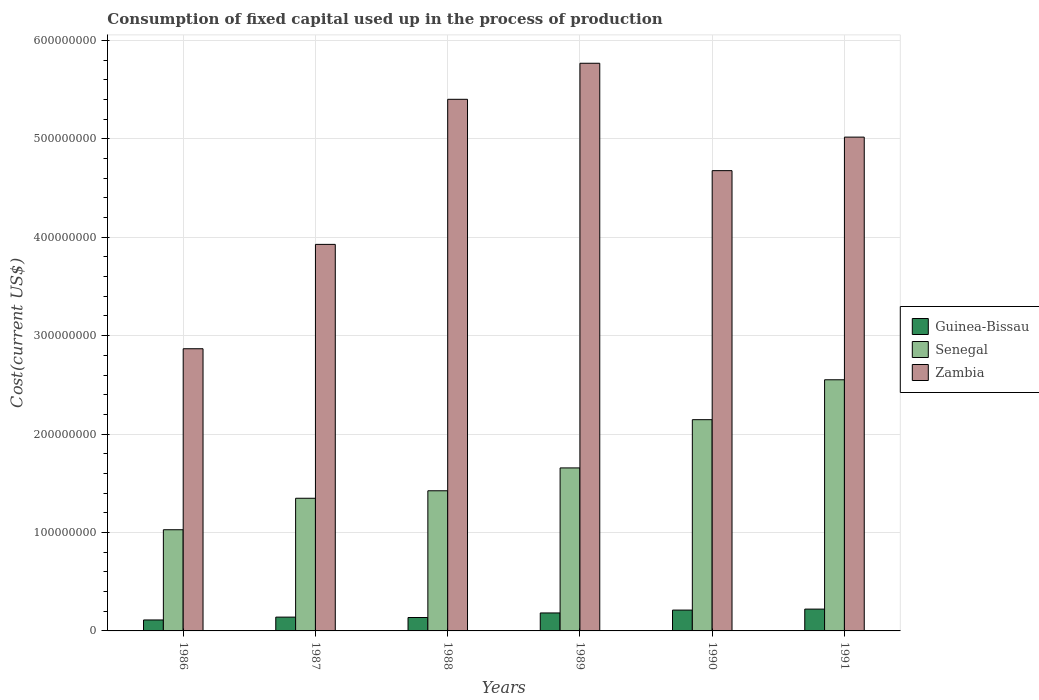How many groups of bars are there?
Ensure brevity in your answer.  6. Are the number of bars on each tick of the X-axis equal?
Provide a succinct answer. Yes. How many bars are there on the 6th tick from the left?
Provide a succinct answer. 3. What is the label of the 4th group of bars from the left?
Offer a very short reply. 1989. In how many cases, is the number of bars for a given year not equal to the number of legend labels?
Make the answer very short. 0. What is the amount consumed in the process of production in Zambia in 1987?
Offer a terse response. 3.93e+08. Across all years, what is the maximum amount consumed in the process of production in Zambia?
Provide a short and direct response. 5.77e+08. Across all years, what is the minimum amount consumed in the process of production in Senegal?
Give a very brief answer. 1.03e+08. In which year was the amount consumed in the process of production in Senegal maximum?
Offer a terse response. 1991. In which year was the amount consumed in the process of production in Zambia minimum?
Your answer should be very brief. 1986. What is the total amount consumed in the process of production in Zambia in the graph?
Ensure brevity in your answer.  2.77e+09. What is the difference between the amount consumed in the process of production in Senegal in 1987 and that in 1991?
Provide a short and direct response. -1.20e+08. What is the difference between the amount consumed in the process of production in Guinea-Bissau in 1988 and the amount consumed in the process of production in Zambia in 1989?
Give a very brief answer. -5.63e+08. What is the average amount consumed in the process of production in Senegal per year?
Your answer should be compact. 1.69e+08. In the year 1991, what is the difference between the amount consumed in the process of production in Zambia and amount consumed in the process of production in Guinea-Bissau?
Provide a succinct answer. 4.80e+08. In how many years, is the amount consumed in the process of production in Senegal greater than 120000000 US$?
Your response must be concise. 5. What is the ratio of the amount consumed in the process of production in Senegal in 1989 to that in 1990?
Offer a terse response. 0.77. Is the amount consumed in the process of production in Zambia in 1986 less than that in 1988?
Offer a very short reply. Yes. Is the difference between the amount consumed in the process of production in Zambia in 1986 and 1989 greater than the difference between the amount consumed in the process of production in Guinea-Bissau in 1986 and 1989?
Make the answer very short. No. What is the difference between the highest and the second highest amount consumed in the process of production in Guinea-Bissau?
Provide a succinct answer. 9.94e+05. What is the difference between the highest and the lowest amount consumed in the process of production in Guinea-Bissau?
Keep it short and to the point. 1.10e+07. What does the 2nd bar from the left in 1991 represents?
Give a very brief answer. Senegal. What does the 2nd bar from the right in 1988 represents?
Provide a succinct answer. Senegal. How many legend labels are there?
Offer a very short reply. 3. What is the title of the graph?
Ensure brevity in your answer.  Consumption of fixed capital used up in the process of production. What is the label or title of the X-axis?
Offer a terse response. Years. What is the label or title of the Y-axis?
Your answer should be very brief. Cost(current US$). What is the Cost(current US$) in Guinea-Bissau in 1986?
Make the answer very short. 1.11e+07. What is the Cost(current US$) of Senegal in 1986?
Offer a very short reply. 1.03e+08. What is the Cost(current US$) of Zambia in 1986?
Your answer should be very brief. 2.87e+08. What is the Cost(current US$) in Guinea-Bissau in 1987?
Provide a short and direct response. 1.40e+07. What is the Cost(current US$) of Senegal in 1987?
Provide a short and direct response. 1.35e+08. What is the Cost(current US$) in Zambia in 1987?
Provide a short and direct response. 3.93e+08. What is the Cost(current US$) in Guinea-Bissau in 1988?
Ensure brevity in your answer.  1.36e+07. What is the Cost(current US$) in Senegal in 1988?
Make the answer very short. 1.42e+08. What is the Cost(current US$) of Zambia in 1988?
Your response must be concise. 5.40e+08. What is the Cost(current US$) of Guinea-Bissau in 1989?
Make the answer very short. 1.83e+07. What is the Cost(current US$) in Senegal in 1989?
Ensure brevity in your answer.  1.66e+08. What is the Cost(current US$) in Zambia in 1989?
Ensure brevity in your answer.  5.77e+08. What is the Cost(current US$) in Guinea-Bissau in 1990?
Your answer should be compact. 2.12e+07. What is the Cost(current US$) in Senegal in 1990?
Your answer should be compact. 2.15e+08. What is the Cost(current US$) in Zambia in 1990?
Offer a very short reply. 4.68e+08. What is the Cost(current US$) in Guinea-Bissau in 1991?
Keep it short and to the point. 2.22e+07. What is the Cost(current US$) of Senegal in 1991?
Keep it short and to the point. 2.55e+08. What is the Cost(current US$) of Zambia in 1991?
Provide a succinct answer. 5.02e+08. Across all years, what is the maximum Cost(current US$) of Guinea-Bissau?
Your response must be concise. 2.22e+07. Across all years, what is the maximum Cost(current US$) of Senegal?
Ensure brevity in your answer.  2.55e+08. Across all years, what is the maximum Cost(current US$) in Zambia?
Provide a short and direct response. 5.77e+08. Across all years, what is the minimum Cost(current US$) of Guinea-Bissau?
Keep it short and to the point. 1.11e+07. Across all years, what is the minimum Cost(current US$) of Senegal?
Ensure brevity in your answer.  1.03e+08. Across all years, what is the minimum Cost(current US$) of Zambia?
Provide a short and direct response. 2.87e+08. What is the total Cost(current US$) of Guinea-Bissau in the graph?
Offer a terse response. 1.00e+08. What is the total Cost(current US$) in Senegal in the graph?
Your answer should be very brief. 1.02e+09. What is the total Cost(current US$) of Zambia in the graph?
Ensure brevity in your answer.  2.77e+09. What is the difference between the Cost(current US$) of Guinea-Bissau in 1986 and that in 1987?
Your answer should be compact. -2.90e+06. What is the difference between the Cost(current US$) of Senegal in 1986 and that in 1987?
Offer a terse response. -3.20e+07. What is the difference between the Cost(current US$) in Zambia in 1986 and that in 1987?
Provide a succinct answer. -1.06e+08. What is the difference between the Cost(current US$) of Guinea-Bissau in 1986 and that in 1988?
Provide a succinct answer. -2.50e+06. What is the difference between the Cost(current US$) in Senegal in 1986 and that in 1988?
Your answer should be compact. -3.96e+07. What is the difference between the Cost(current US$) in Zambia in 1986 and that in 1988?
Offer a terse response. -2.53e+08. What is the difference between the Cost(current US$) of Guinea-Bissau in 1986 and that in 1989?
Your response must be concise. -7.13e+06. What is the difference between the Cost(current US$) of Senegal in 1986 and that in 1989?
Provide a short and direct response. -6.28e+07. What is the difference between the Cost(current US$) in Zambia in 1986 and that in 1989?
Make the answer very short. -2.90e+08. What is the difference between the Cost(current US$) of Guinea-Bissau in 1986 and that in 1990?
Give a very brief answer. -1.00e+07. What is the difference between the Cost(current US$) of Senegal in 1986 and that in 1990?
Your answer should be compact. -1.12e+08. What is the difference between the Cost(current US$) in Zambia in 1986 and that in 1990?
Your response must be concise. -1.81e+08. What is the difference between the Cost(current US$) in Guinea-Bissau in 1986 and that in 1991?
Offer a terse response. -1.10e+07. What is the difference between the Cost(current US$) in Senegal in 1986 and that in 1991?
Provide a succinct answer. -1.52e+08. What is the difference between the Cost(current US$) of Zambia in 1986 and that in 1991?
Ensure brevity in your answer.  -2.15e+08. What is the difference between the Cost(current US$) in Guinea-Bissau in 1987 and that in 1988?
Your response must be concise. 4.03e+05. What is the difference between the Cost(current US$) of Senegal in 1987 and that in 1988?
Keep it short and to the point. -7.61e+06. What is the difference between the Cost(current US$) in Zambia in 1987 and that in 1988?
Offer a terse response. -1.47e+08. What is the difference between the Cost(current US$) of Guinea-Bissau in 1987 and that in 1989?
Make the answer very short. -4.23e+06. What is the difference between the Cost(current US$) of Senegal in 1987 and that in 1989?
Offer a terse response. -3.08e+07. What is the difference between the Cost(current US$) in Zambia in 1987 and that in 1989?
Give a very brief answer. -1.84e+08. What is the difference between the Cost(current US$) of Guinea-Bissau in 1987 and that in 1990?
Give a very brief answer. -7.14e+06. What is the difference between the Cost(current US$) of Senegal in 1987 and that in 1990?
Give a very brief answer. -7.98e+07. What is the difference between the Cost(current US$) in Zambia in 1987 and that in 1990?
Keep it short and to the point. -7.49e+07. What is the difference between the Cost(current US$) of Guinea-Bissau in 1987 and that in 1991?
Provide a succinct answer. -8.14e+06. What is the difference between the Cost(current US$) of Senegal in 1987 and that in 1991?
Provide a short and direct response. -1.20e+08. What is the difference between the Cost(current US$) in Zambia in 1987 and that in 1991?
Your answer should be compact. -1.09e+08. What is the difference between the Cost(current US$) in Guinea-Bissau in 1988 and that in 1989?
Ensure brevity in your answer.  -4.64e+06. What is the difference between the Cost(current US$) of Senegal in 1988 and that in 1989?
Offer a very short reply. -2.32e+07. What is the difference between the Cost(current US$) of Zambia in 1988 and that in 1989?
Your answer should be compact. -3.66e+07. What is the difference between the Cost(current US$) of Guinea-Bissau in 1988 and that in 1990?
Offer a terse response. -7.55e+06. What is the difference between the Cost(current US$) in Senegal in 1988 and that in 1990?
Your response must be concise. -7.22e+07. What is the difference between the Cost(current US$) of Zambia in 1988 and that in 1990?
Your answer should be compact. 7.25e+07. What is the difference between the Cost(current US$) in Guinea-Bissau in 1988 and that in 1991?
Offer a very short reply. -8.54e+06. What is the difference between the Cost(current US$) in Senegal in 1988 and that in 1991?
Provide a short and direct response. -1.13e+08. What is the difference between the Cost(current US$) in Zambia in 1988 and that in 1991?
Offer a very short reply. 3.84e+07. What is the difference between the Cost(current US$) in Guinea-Bissau in 1989 and that in 1990?
Your answer should be very brief. -2.91e+06. What is the difference between the Cost(current US$) in Senegal in 1989 and that in 1990?
Your answer should be very brief. -4.90e+07. What is the difference between the Cost(current US$) in Zambia in 1989 and that in 1990?
Your response must be concise. 1.09e+08. What is the difference between the Cost(current US$) of Guinea-Bissau in 1989 and that in 1991?
Give a very brief answer. -3.91e+06. What is the difference between the Cost(current US$) in Senegal in 1989 and that in 1991?
Provide a succinct answer. -8.96e+07. What is the difference between the Cost(current US$) of Zambia in 1989 and that in 1991?
Your response must be concise. 7.51e+07. What is the difference between the Cost(current US$) of Guinea-Bissau in 1990 and that in 1991?
Provide a short and direct response. -9.94e+05. What is the difference between the Cost(current US$) in Senegal in 1990 and that in 1991?
Make the answer very short. -4.06e+07. What is the difference between the Cost(current US$) in Zambia in 1990 and that in 1991?
Keep it short and to the point. -3.41e+07. What is the difference between the Cost(current US$) of Guinea-Bissau in 1986 and the Cost(current US$) of Senegal in 1987?
Your answer should be very brief. -1.24e+08. What is the difference between the Cost(current US$) in Guinea-Bissau in 1986 and the Cost(current US$) in Zambia in 1987?
Give a very brief answer. -3.82e+08. What is the difference between the Cost(current US$) in Senegal in 1986 and the Cost(current US$) in Zambia in 1987?
Provide a succinct answer. -2.90e+08. What is the difference between the Cost(current US$) in Guinea-Bissau in 1986 and the Cost(current US$) in Senegal in 1988?
Your response must be concise. -1.31e+08. What is the difference between the Cost(current US$) in Guinea-Bissau in 1986 and the Cost(current US$) in Zambia in 1988?
Give a very brief answer. -5.29e+08. What is the difference between the Cost(current US$) of Senegal in 1986 and the Cost(current US$) of Zambia in 1988?
Your response must be concise. -4.37e+08. What is the difference between the Cost(current US$) in Guinea-Bissau in 1986 and the Cost(current US$) in Senegal in 1989?
Give a very brief answer. -1.55e+08. What is the difference between the Cost(current US$) of Guinea-Bissau in 1986 and the Cost(current US$) of Zambia in 1989?
Provide a short and direct response. -5.66e+08. What is the difference between the Cost(current US$) of Senegal in 1986 and the Cost(current US$) of Zambia in 1989?
Offer a very short reply. -4.74e+08. What is the difference between the Cost(current US$) of Guinea-Bissau in 1986 and the Cost(current US$) of Senegal in 1990?
Provide a short and direct response. -2.04e+08. What is the difference between the Cost(current US$) in Guinea-Bissau in 1986 and the Cost(current US$) in Zambia in 1990?
Provide a short and direct response. -4.57e+08. What is the difference between the Cost(current US$) of Senegal in 1986 and the Cost(current US$) of Zambia in 1990?
Your answer should be compact. -3.65e+08. What is the difference between the Cost(current US$) of Guinea-Bissau in 1986 and the Cost(current US$) of Senegal in 1991?
Provide a succinct answer. -2.44e+08. What is the difference between the Cost(current US$) in Guinea-Bissau in 1986 and the Cost(current US$) in Zambia in 1991?
Provide a succinct answer. -4.91e+08. What is the difference between the Cost(current US$) in Senegal in 1986 and the Cost(current US$) in Zambia in 1991?
Keep it short and to the point. -3.99e+08. What is the difference between the Cost(current US$) of Guinea-Bissau in 1987 and the Cost(current US$) of Senegal in 1988?
Your response must be concise. -1.28e+08. What is the difference between the Cost(current US$) in Guinea-Bissau in 1987 and the Cost(current US$) in Zambia in 1988?
Offer a terse response. -5.26e+08. What is the difference between the Cost(current US$) in Senegal in 1987 and the Cost(current US$) in Zambia in 1988?
Your response must be concise. -4.05e+08. What is the difference between the Cost(current US$) in Guinea-Bissau in 1987 and the Cost(current US$) in Senegal in 1989?
Keep it short and to the point. -1.52e+08. What is the difference between the Cost(current US$) in Guinea-Bissau in 1987 and the Cost(current US$) in Zambia in 1989?
Your response must be concise. -5.63e+08. What is the difference between the Cost(current US$) in Senegal in 1987 and the Cost(current US$) in Zambia in 1989?
Offer a terse response. -4.42e+08. What is the difference between the Cost(current US$) in Guinea-Bissau in 1987 and the Cost(current US$) in Senegal in 1990?
Give a very brief answer. -2.01e+08. What is the difference between the Cost(current US$) of Guinea-Bissau in 1987 and the Cost(current US$) of Zambia in 1990?
Make the answer very short. -4.54e+08. What is the difference between the Cost(current US$) of Senegal in 1987 and the Cost(current US$) of Zambia in 1990?
Offer a very short reply. -3.33e+08. What is the difference between the Cost(current US$) of Guinea-Bissau in 1987 and the Cost(current US$) of Senegal in 1991?
Offer a very short reply. -2.41e+08. What is the difference between the Cost(current US$) in Guinea-Bissau in 1987 and the Cost(current US$) in Zambia in 1991?
Offer a terse response. -4.88e+08. What is the difference between the Cost(current US$) of Senegal in 1987 and the Cost(current US$) of Zambia in 1991?
Your answer should be compact. -3.67e+08. What is the difference between the Cost(current US$) of Guinea-Bissau in 1988 and the Cost(current US$) of Senegal in 1989?
Your answer should be very brief. -1.52e+08. What is the difference between the Cost(current US$) in Guinea-Bissau in 1988 and the Cost(current US$) in Zambia in 1989?
Keep it short and to the point. -5.63e+08. What is the difference between the Cost(current US$) in Senegal in 1988 and the Cost(current US$) in Zambia in 1989?
Make the answer very short. -4.34e+08. What is the difference between the Cost(current US$) in Guinea-Bissau in 1988 and the Cost(current US$) in Senegal in 1990?
Your answer should be very brief. -2.01e+08. What is the difference between the Cost(current US$) of Guinea-Bissau in 1988 and the Cost(current US$) of Zambia in 1990?
Offer a terse response. -4.54e+08. What is the difference between the Cost(current US$) in Senegal in 1988 and the Cost(current US$) in Zambia in 1990?
Give a very brief answer. -3.25e+08. What is the difference between the Cost(current US$) of Guinea-Bissau in 1988 and the Cost(current US$) of Senegal in 1991?
Ensure brevity in your answer.  -2.42e+08. What is the difference between the Cost(current US$) in Guinea-Bissau in 1988 and the Cost(current US$) in Zambia in 1991?
Your answer should be very brief. -4.88e+08. What is the difference between the Cost(current US$) of Senegal in 1988 and the Cost(current US$) of Zambia in 1991?
Offer a very short reply. -3.59e+08. What is the difference between the Cost(current US$) in Guinea-Bissau in 1989 and the Cost(current US$) in Senegal in 1990?
Make the answer very short. -1.96e+08. What is the difference between the Cost(current US$) in Guinea-Bissau in 1989 and the Cost(current US$) in Zambia in 1990?
Give a very brief answer. -4.49e+08. What is the difference between the Cost(current US$) in Senegal in 1989 and the Cost(current US$) in Zambia in 1990?
Your answer should be compact. -3.02e+08. What is the difference between the Cost(current US$) in Guinea-Bissau in 1989 and the Cost(current US$) in Senegal in 1991?
Keep it short and to the point. -2.37e+08. What is the difference between the Cost(current US$) in Guinea-Bissau in 1989 and the Cost(current US$) in Zambia in 1991?
Offer a terse response. -4.83e+08. What is the difference between the Cost(current US$) in Senegal in 1989 and the Cost(current US$) in Zambia in 1991?
Offer a very short reply. -3.36e+08. What is the difference between the Cost(current US$) in Guinea-Bissau in 1990 and the Cost(current US$) in Senegal in 1991?
Your answer should be very brief. -2.34e+08. What is the difference between the Cost(current US$) of Guinea-Bissau in 1990 and the Cost(current US$) of Zambia in 1991?
Provide a short and direct response. -4.81e+08. What is the difference between the Cost(current US$) of Senegal in 1990 and the Cost(current US$) of Zambia in 1991?
Provide a short and direct response. -2.87e+08. What is the average Cost(current US$) of Guinea-Bissau per year?
Give a very brief answer. 1.67e+07. What is the average Cost(current US$) in Senegal per year?
Your answer should be compact. 1.69e+08. What is the average Cost(current US$) in Zambia per year?
Your answer should be very brief. 4.61e+08. In the year 1986, what is the difference between the Cost(current US$) in Guinea-Bissau and Cost(current US$) in Senegal?
Your answer should be very brief. -9.17e+07. In the year 1986, what is the difference between the Cost(current US$) of Guinea-Bissau and Cost(current US$) of Zambia?
Offer a terse response. -2.76e+08. In the year 1986, what is the difference between the Cost(current US$) of Senegal and Cost(current US$) of Zambia?
Provide a succinct answer. -1.84e+08. In the year 1987, what is the difference between the Cost(current US$) in Guinea-Bissau and Cost(current US$) in Senegal?
Provide a succinct answer. -1.21e+08. In the year 1987, what is the difference between the Cost(current US$) of Guinea-Bissau and Cost(current US$) of Zambia?
Your response must be concise. -3.79e+08. In the year 1987, what is the difference between the Cost(current US$) of Senegal and Cost(current US$) of Zambia?
Your response must be concise. -2.58e+08. In the year 1988, what is the difference between the Cost(current US$) in Guinea-Bissau and Cost(current US$) in Senegal?
Make the answer very short. -1.29e+08. In the year 1988, what is the difference between the Cost(current US$) of Guinea-Bissau and Cost(current US$) of Zambia?
Make the answer very short. -5.27e+08. In the year 1988, what is the difference between the Cost(current US$) of Senegal and Cost(current US$) of Zambia?
Make the answer very short. -3.98e+08. In the year 1989, what is the difference between the Cost(current US$) in Guinea-Bissau and Cost(current US$) in Senegal?
Your answer should be very brief. -1.47e+08. In the year 1989, what is the difference between the Cost(current US$) of Guinea-Bissau and Cost(current US$) of Zambia?
Offer a terse response. -5.59e+08. In the year 1989, what is the difference between the Cost(current US$) of Senegal and Cost(current US$) of Zambia?
Offer a terse response. -4.11e+08. In the year 1990, what is the difference between the Cost(current US$) in Guinea-Bissau and Cost(current US$) in Senegal?
Provide a short and direct response. -1.93e+08. In the year 1990, what is the difference between the Cost(current US$) in Guinea-Bissau and Cost(current US$) in Zambia?
Offer a terse response. -4.47e+08. In the year 1990, what is the difference between the Cost(current US$) of Senegal and Cost(current US$) of Zambia?
Make the answer very short. -2.53e+08. In the year 1991, what is the difference between the Cost(current US$) in Guinea-Bissau and Cost(current US$) in Senegal?
Your answer should be compact. -2.33e+08. In the year 1991, what is the difference between the Cost(current US$) in Guinea-Bissau and Cost(current US$) in Zambia?
Offer a very short reply. -4.80e+08. In the year 1991, what is the difference between the Cost(current US$) in Senegal and Cost(current US$) in Zambia?
Make the answer very short. -2.47e+08. What is the ratio of the Cost(current US$) in Guinea-Bissau in 1986 to that in 1987?
Make the answer very short. 0.79. What is the ratio of the Cost(current US$) of Senegal in 1986 to that in 1987?
Make the answer very short. 0.76. What is the ratio of the Cost(current US$) of Zambia in 1986 to that in 1987?
Offer a terse response. 0.73. What is the ratio of the Cost(current US$) in Guinea-Bissau in 1986 to that in 1988?
Your answer should be compact. 0.82. What is the ratio of the Cost(current US$) of Senegal in 1986 to that in 1988?
Your answer should be very brief. 0.72. What is the ratio of the Cost(current US$) in Zambia in 1986 to that in 1988?
Give a very brief answer. 0.53. What is the ratio of the Cost(current US$) of Guinea-Bissau in 1986 to that in 1989?
Give a very brief answer. 0.61. What is the ratio of the Cost(current US$) in Senegal in 1986 to that in 1989?
Your response must be concise. 0.62. What is the ratio of the Cost(current US$) of Zambia in 1986 to that in 1989?
Offer a terse response. 0.5. What is the ratio of the Cost(current US$) in Guinea-Bissau in 1986 to that in 1990?
Your answer should be very brief. 0.53. What is the ratio of the Cost(current US$) of Senegal in 1986 to that in 1990?
Keep it short and to the point. 0.48. What is the ratio of the Cost(current US$) of Zambia in 1986 to that in 1990?
Keep it short and to the point. 0.61. What is the ratio of the Cost(current US$) of Guinea-Bissau in 1986 to that in 1991?
Offer a very short reply. 0.5. What is the ratio of the Cost(current US$) of Senegal in 1986 to that in 1991?
Ensure brevity in your answer.  0.4. What is the ratio of the Cost(current US$) of Guinea-Bissau in 1987 to that in 1988?
Offer a terse response. 1.03. What is the ratio of the Cost(current US$) in Senegal in 1987 to that in 1988?
Ensure brevity in your answer.  0.95. What is the ratio of the Cost(current US$) in Zambia in 1987 to that in 1988?
Your answer should be compact. 0.73. What is the ratio of the Cost(current US$) of Guinea-Bissau in 1987 to that in 1989?
Your response must be concise. 0.77. What is the ratio of the Cost(current US$) in Senegal in 1987 to that in 1989?
Provide a short and direct response. 0.81. What is the ratio of the Cost(current US$) in Zambia in 1987 to that in 1989?
Your response must be concise. 0.68. What is the ratio of the Cost(current US$) of Guinea-Bissau in 1987 to that in 1990?
Provide a short and direct response. 0.66. What is the ratio of the Cost(current US$) in Senegal in 1987 to that in 1990?
Your answer should be very brief. 0.63. What is the ratio of the Cost(current US$) in Zambia in 1987 to that in 1990?
Give a very brief answer. 0.84. What is the ratio of the Cost(current US$) of Guinea-Bissau in 1987 to that in 1991?
Provide a succinct answer. 0.63. What is the ratio of the Cost(current US$) of Senegal in 1987 to that in 1991?
Your answer should be very brief. 0.53. What is the ratio of the Cost(current US$) in Zambia in 1987 to that in 1991?
Offer a terse response. 0.78. What is the ratio of the Cost(current US$) in Guinea-Bissau in 1988 to that in 1989?
Make the answer very short. 0.75. What is the ratio of the Cost(current US$) of Senegal in 1988 to that in 1989?
Offer a terse response. 0.86. What is the ratio of the Cost(current US$) of Zambia in 1988 to that in 1989?
Your answer should be very brief. 0.94. What is the ratio of the Cost(current US$) of Guinea-Bissau in 1988 to that in 1990?
Provide a short and direct response. 0.64. What is the ratio of the Cost(current US$) in Senegal in 1988 to that in 1990?
Provide a short and direct response. 0.66. What is the ratio of the Cost(current US$) in Zambia in 1988 to that in 1990?
Your answer should be very brief. 1.16. What is the ratio of the Cost(current US$) of Guinea-Bissau in 1988 to that in 1991?
Your response must be concise. 0.61. What is the ratio of the Cost(current US$) in Senegal in 1988 to that in 1991?
Your response must be concise. 0.56. What is the ratio of the Cost(current US$) of Zambia in 1988 to that in 1991?
Your answer should be very brief. 1.08. What is the ratio of the Cost(current US$) in Guinea-Bissau in 1989 to that in 1990?
Your answer should be very brief. 0.86. What is the ratio of the Cost(current US$) in Senegal in 1989 to that in 1990?
Make the answer very short. 0.77. What is the ratio of the Cost(current US$) in Zambia in 1989 to that in 1990?
Provide a short and direct response. 1.23. What is the ratio of the Cost(current US$) of Guinea-Bissau in 1989 to that in 1991?
Provide a short and direct response. 0.82. What is the ratio of the Cost(current US$) in Senegal in 1989 to that in 1991?
Make the answer very short. 0.65. What is the ratio of the Cost(current US$) in Zambia in 1989 to that in 1991?
Provide a short and direct response. 1.15. What is the ratio of the Cost(current US$) in Guinea-Bissau in 1990 to that in 1991?
Offer a very short reply. 0.96. What is the ratio of the Cost(current US$) in Senegal in 1990 to that in 1991?
Your response must be concise. 0.84. What is the ratio of the Cost(current US$) of Zambia in 1990 to that in 1991?
Your response must be concise. 0.93. What is the difference between the highest and the second highest Cost(current US$) in Guinea-Bissau?
Ensure brevity in your answer.  9.94e+05. What is the difference between the highest and the second highest Cost(current US$) in Senegal?
Your answer should be compact. 4.06e+07. What is the difference between the highest and the second highest Cost(current US$) in Zambia?
Ensure brevity in your answer.  3.66e+07. What is the difference between the highest and the lowest Cost(current US$) in Guinea-Bissau?
Your answer should be compact. 1.10e+07. What is the difference between the highest and the lowest Cost(current US$) of Senegal?
Make the answer very short. 1.52e+08. What is the difference between the highest and the lowest Cost(current US$) in Zambia?
Give a very brief answer. 2.90e+08. 